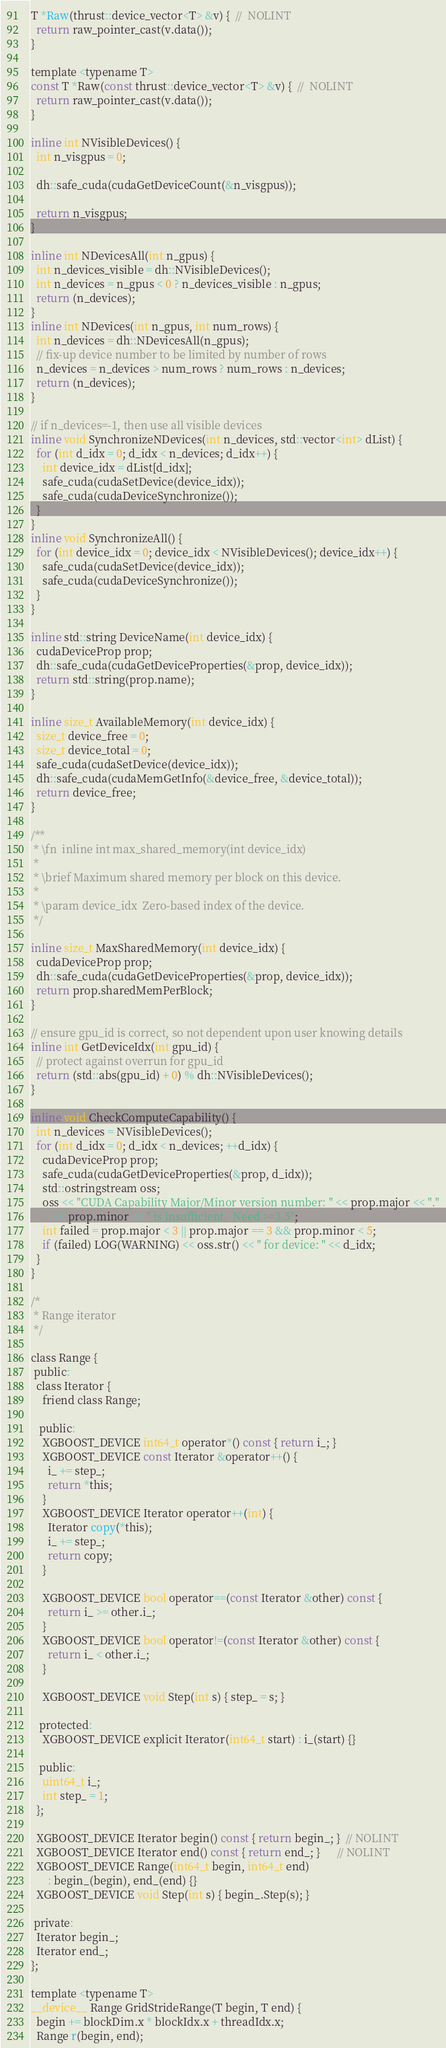Convert code to text. <code><loc_0><loc_0><loc_500><loc_500><_Cuda_>T *Raw(thrust::device_vector<T> &v) {  //  NOLINT
  return raw_pointer_cast(v.data());
}

template <typename T>
const T *Raw(const thrust::device_vector<T> &v) {  //  NOLINT
  return raw_pointer_cast(v.data());
}

inline int NVisibleDevices() {
  int n_visgpus = 0;

  dh::safe_cuda(cudaGetDeviceCount(&n_visgpus));

  return n_visgpus;
}

inline int NDevicesAll(int n_gpus) {
  int n_devices_visible = dh::NVisibleDevices();
  int n_devices = n_gpus < 0 ? n_devices_visible : n_gpus;
  return (n_devices);
}
inline int NDevices(int n_gpus, int num_rows) {
  int n_devices = dh::NDevicesAll(n_gpus);
  // fix-up device number to be limited by number of rows
  n_devices = n_devices > num_rows ? num_rows : n_devices;
  return (n_devices);
}

// if n_devices=-1, then use all visible devices
inline void SynchronizeNDevices(int n_devices, std::vector<int> dList) {
  for (int d_idx = 0; d_idx < n_devices; d_idx++) {
    int device_idx = dList[d_idx];
    safe_cuda(cudaSetDevice(device_idx));
    safe_cuda(cudaDeviceSynchronize());
  }
}
inline void SynchronizeAll() {
  for (int device_idx = 0; device_idx < NVisibleDevices(); device_idx++) {
    safe_cuda(cudaSetDevice(device_idx));
    safe_cuda(cudaDeviceSynchronize());
  }
}

inline std::string DeviceName(int device_idx) {
  cudaDeviceProp prop;
  dh::safe_cuda(cudaGetDeviceProperties(&prop, device_idx));
  return std::string(prop.name);
}

inline size_t AvailableMemory(int device_idx) {
  size_t device_free = 0;
  size_t device_total = 0;
  safe_cuda(cudaSetDevice(device_idx));
  dh::safe_cuda(cudaMemGetInfo(&device_free, &device_total));
  return device_free;
}

/**
 * \fn  inline int max_shared_memory(int device_idx)
 *
 * \brief Maximum shared memory per block on this device.
 *
 * \param device_idx  Zero-based index of the device.
 */

inline size_t MaxSharedMemory(int device_idx) {
  cudaDeviceProp prop;
  dh::safe_cuda(cudaGetDeviceProperties(&prop, device_idx));
  return prop.sharedMemPerBlock;
}

// ensure gpu_id is correct, so not dependent upon user knowing details
inline int GetDeviceIdx(int gpu_id) {
  // protect against overrun for gpu_id
  return (std::abs(gpu_id) + 0) % dh::NVisibleDevices();
}

inline void CheckComputeCapability() {
  int n_devices = NVisibleDevices();
  for (int d_idx = 0; d_idx < n_devices; ++d_idx) {
    cudaDeviceProp prop;
    safe_cuda(cudaGetDeviceProperties(&prop, d_idx));
    std::ostringstream oss;
    oss << "CUDA Capability Major/Minor version number: " << prop.major << "."
        << prop.minor << " is insufficient.  Need >=3.5";
    int failed = prop.major < 3 || prop.major == 3 && prop.minor < 5;
    if (failed) LOG(WARNING) << oss.str() << " for device: " << d_idx;
  }
}

/*
 * Range iterator
 */

class Range {
 public:
  class Iterator {
    friend class Range;

   public:
    XGBOOST_DEVICE int64_t operator*() const { return i_; }
    XGBOOST_DEVICE const Iterator &operator++() {
      i_ += step_;
      return *this;
    }
    XGBOOST_DEVICE Iterator operator++(int) {
      Iterator copy(*this);
      i_ += step_;
      return copy;
    }

    XGBOOST_DEVICE bool operator==(const Iterator &other) const {
      return i_ >= other.i_;
    }
    XGBOOST_DEVICE bool operator!=(const Iterator &other) const {
      return i_ < other.i_;
    }

    XGBOOST_DEVICE void Step(int s) { step_ = s; }

   protected:
    XGBOOST_DEVICE explicit Iterator(int64_t start) : i_(start) {}

   public:
    uint64_t i_;
    int step_ = 1;
  };

  XGBOOST_DEVICE Iterator begin() const { return begin_; }  // NOLINT
  XGBOOST_DEVICE Iterator end() const { return end_; }      // NOLINT
  XGBOOST_DEVICE Range(int64_t begin, int64_t end)
      : begin_(begin), end_(end) {}
  XGBOOST_DEVICE void Step(int s) { begin_.Step(s); }

 private:
  Iterator begin_;
  Iterator end_;
};

template <typename T>
__device__ Range GridStrideRange(T begin, T end) {
  begin += blockDim.x * blockIdx.x + threadIdx.x;
  Range r(begin, end);</code> 